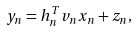<formula> <loc_0><loc_0><loc_500><loc_500>{ y _ { n } } = { { h } _ { n } ^ { T } { v } _ { n } x _ { n } + z _ { n } } ,</formula> 